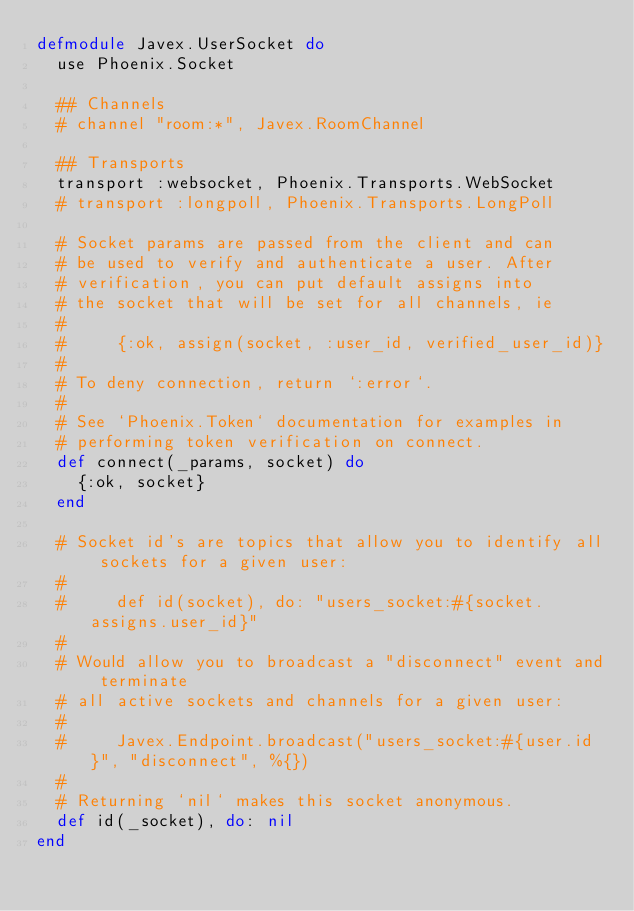Convert code to text. <code><loc_0><loc_0><loc_500><loc_500><_Elixir_>defmodule Javex.UserSocket do
  use Phoenix.Socket

  ## Channels
  # channel "room:*", Javex.RoomChannel

  ## Transports
  transport :websocket, Phoenix.Transports.WebSocket
  # transport :longpoll, Phoenix.Transports.LongPoll

  # Socket params are passed from the client and can
  # be used to verify and authenticate a user. After
  # verification, you can put default assigns into
  # the socket that will be set for all channels, ie
  #
  #     {:ok, assign(socket, :user_id, verified_user_id)}
  #
  # To deny connection, return `:error`.
  #
  # See `Phoenix.Token` documentation for examples in
  # performing token verification on connect.
  def connect(_params, socket) do
    {:ok, socket}
  end

  # Socket id's are topics that allow you to identify all sockets for a given user:
  #
  #     def id(socket), do: "users_socket:#{socket.assigns.user_id}"
  #
  # Would allow you to broadcast a "disconnect" event and terminate
  # all active sockets and channels for a given user:
  #
  #     Javex.Endpoint.broadcast("users_socket:#{user.id}", "disconnect", %{})
  #
  # Returning `nil` makes this socket anonymous.
  def id(_socket), do: nil
end
</code> 